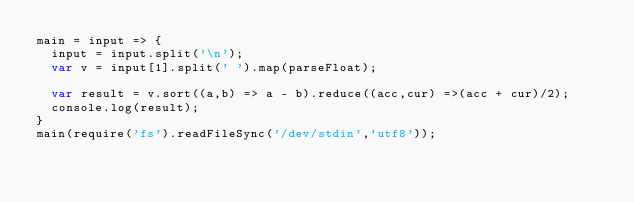Convert code to text. <code><loc_0><loc_0><loc_500><loc_500><_JavaScript_>main = input => {
  input = input.split('\n');
  var v = input[1].split(' ').map(parseFloat);
  
  var result = v.sort((a,b) => a - b).reduce((acc,cur) =>(acc + cur)/2);
  console.log(result);
}
main(require('fs').readFileSync('/dev/stdin','utf8'));</code> 